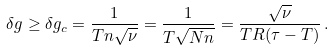<formula> <loc_0><loc_0><loc_500><loc_500>\delta g \geq \delta g _ { c } = \frac { 1 } { T n \sqrt { \nu } } = \frac { 1 } { T \sqrt { N n } } = \frac { \sqrt { \nu } } { T R ( \tau - T ) } \, .</formula> 